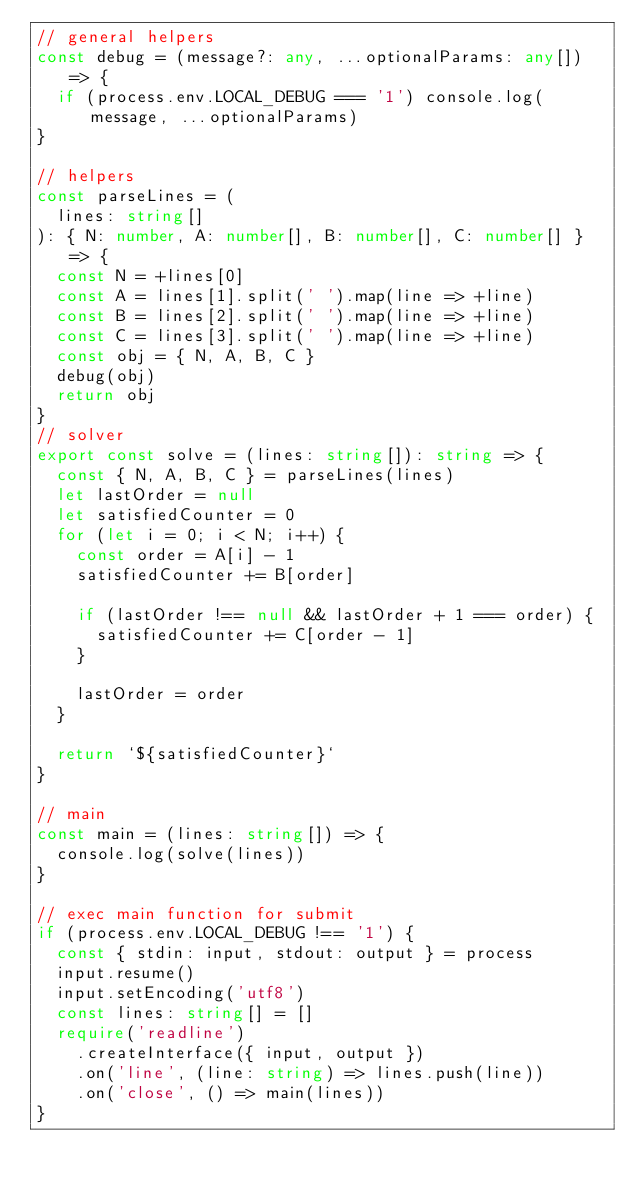Convert code to text. <code><loc_0><loc_0><loc_500><loc_500><_TypeScript_>// general helpers
const debug = (message?: any, ...optionalParams: any[]) => {
  if (process.env.LOCAL_DEBUG === '1') console.log(message, ...optionalParams)
}

// helpers
const parseLines = (
  lines: string[]
): { N: number, A: number[], B: number[], C: number[] } => {
  const N = +lines[0]
  const A = lines[1].split(' ').map(line => +line)
  const B = lines[2].split(' ').map(line => +line)
  const C = lines[3].split(' ').map(line => +line)
  const obj = { N, A, B, C }
  debug(obj)
  return obj
}
// solver
export const solve = (lines: string[]): string => {
  const { N, A, B, C } = parseLines(lines)
  let lastOrder = null
  let satisfiedCounter = 0
  for (let i = 0; i < N; i++) {
    const order = A[i] - 1
    satisfiedCounter += B[order]

    if (lastOrder !== null && lastOrder + 1 === order) {
      satisfiedCounter += C[order - 1]
    }

    lastOrder = order
  }

  return `${satisfiedCounter}`
}

// main
const main = (lines: string[]) => {
  console.log(solve(lines))
}

// exec main function for submit
if (process.env.LOCAL_DEBUG !== '1') {
  const { stdin: input, stdout: output } = process
  input.resume()
  input.setEncoding('utf8')
  const lines: string[] = []
  require('readline')
    .createInterface({ input, output })
    .on('line', (line: string) => lines.push(line))
    .on('close', () => main(lines))
}
</code> 